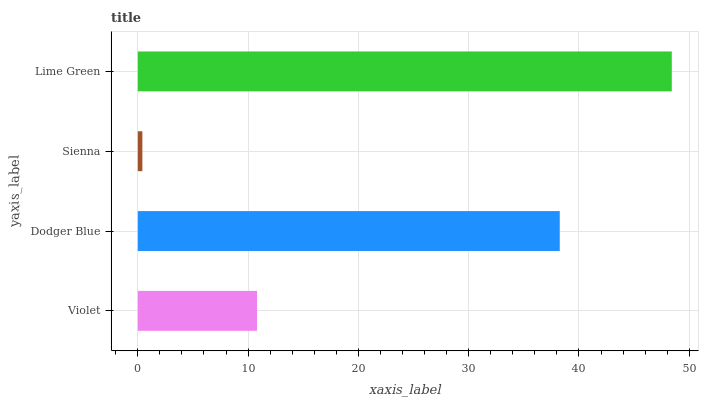Is Sienna the minimum?
Answer yes or no. Yes. Is Lime Green the maximum?
Answer yes or no. Yes. Is Dodger Blue the minimum?
Answer yes or no. No. Is Dodger Blue the maximum?
Answer yes or no. No. Is Dodger Blue greater than Violet?
Answer yes or no. Yes. Is Violet less than Dodger Blue?
Answer yes or no. Yes. Is Violet greater than Dodger Blue?
Answer yes or no. No. Is Dodger Blue less than Violet?
Answer yes or no. No. Is Dodger Blue the high median?
Answer yes or no. Yes. Is Violet the low median?
Answer yes or no. Yes. Is Lime Green the high median?
Answer yes or no. No. Is Sienna the low median?
Answer yes or no. No. 